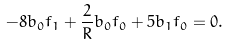<formula> <loc_0><loc_0><loc_500><loc_500>- 8 b _ { 0 } f _ { 1 } + \frac { 2 } { R } b _ { 0 } f _ { 0 } + 5 b _ { 1 } f _ { 0 } = 0 .</formula> 